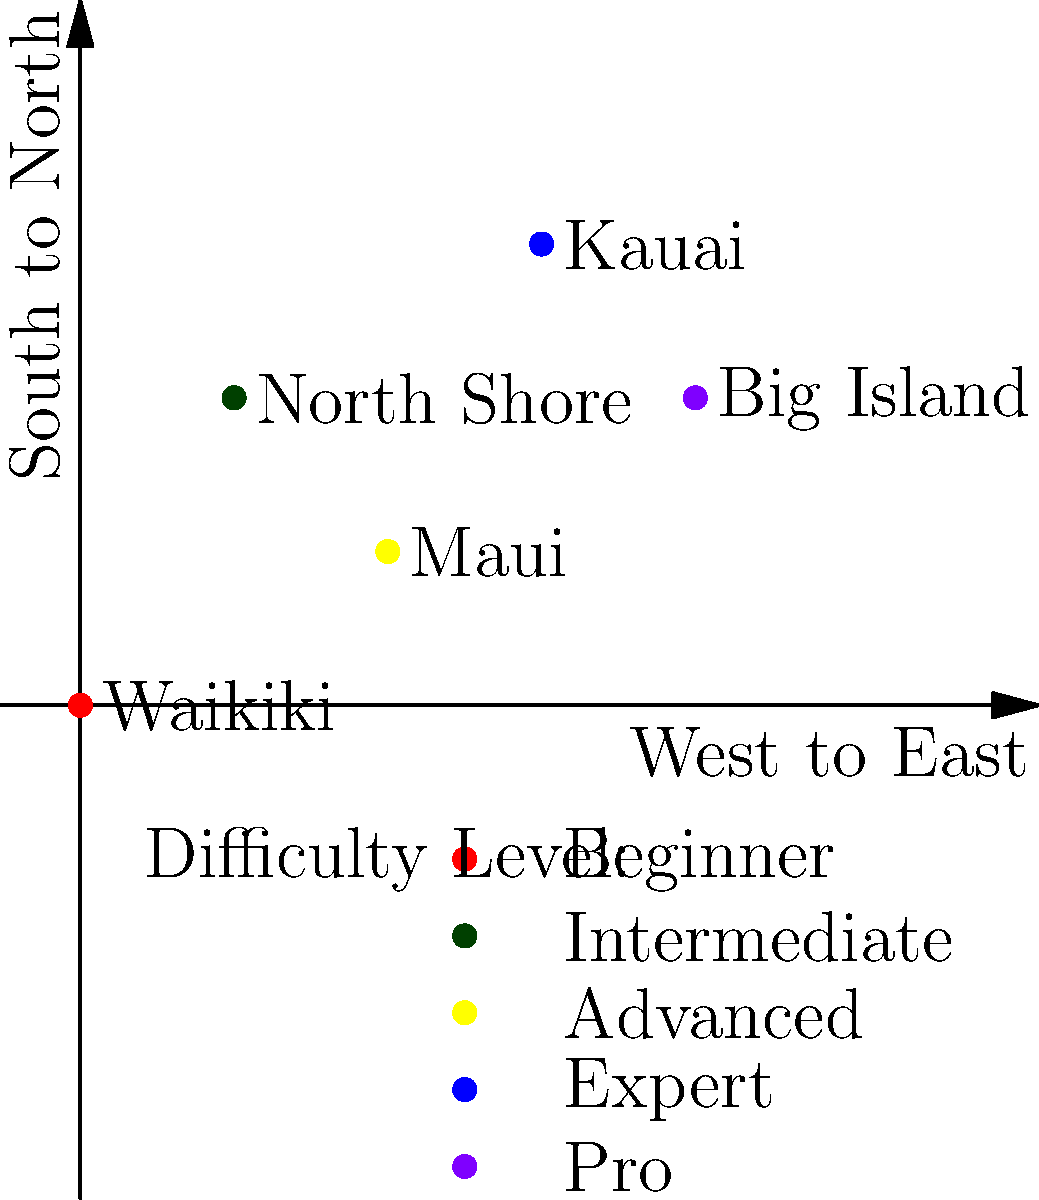Based on the color-coded map of Hawaii's surf spots, which location would be most suitable for a beginner surfer looking to improve their skills while still having access to more challenging waves as they progress? To answer this question, we need to analyze the color-coded difficulty levels of each surf spot on the map:

1. Waikiki (red): Beginner level
2. North Shore (dark green): Intermediate level
3. Maui (yellow): Advanced level
4. Kauai (blue): Expert level
5. Big Island (purple): Pro level

For a beginner surfer looking to improve their skills:

1. They should start with a location that has beginner-friendly waves, which is Waikiki (red).
2. As they progress, they'll want access to slightly more challenging waves, which can be found at the North Shore (dark green).
3. The ideal location should have a mix of beginner and intermediate waves, allowing for skill progression.
4. Waikiki is closer to the North Shore than other locations, making it easier to transition between the two as skills improve.
5. The other locations (Maui, Kauai, and Big Island) are too advanced for a beginner and don't offer suitable conditions for learning.

Therefore, the most suitable location for a beginner surfer looking to improve their skills while still having access to more challenging waves as they progress would be Waikiki, with the option to visit the North Shore as they advance.
Answer: Waikiki 